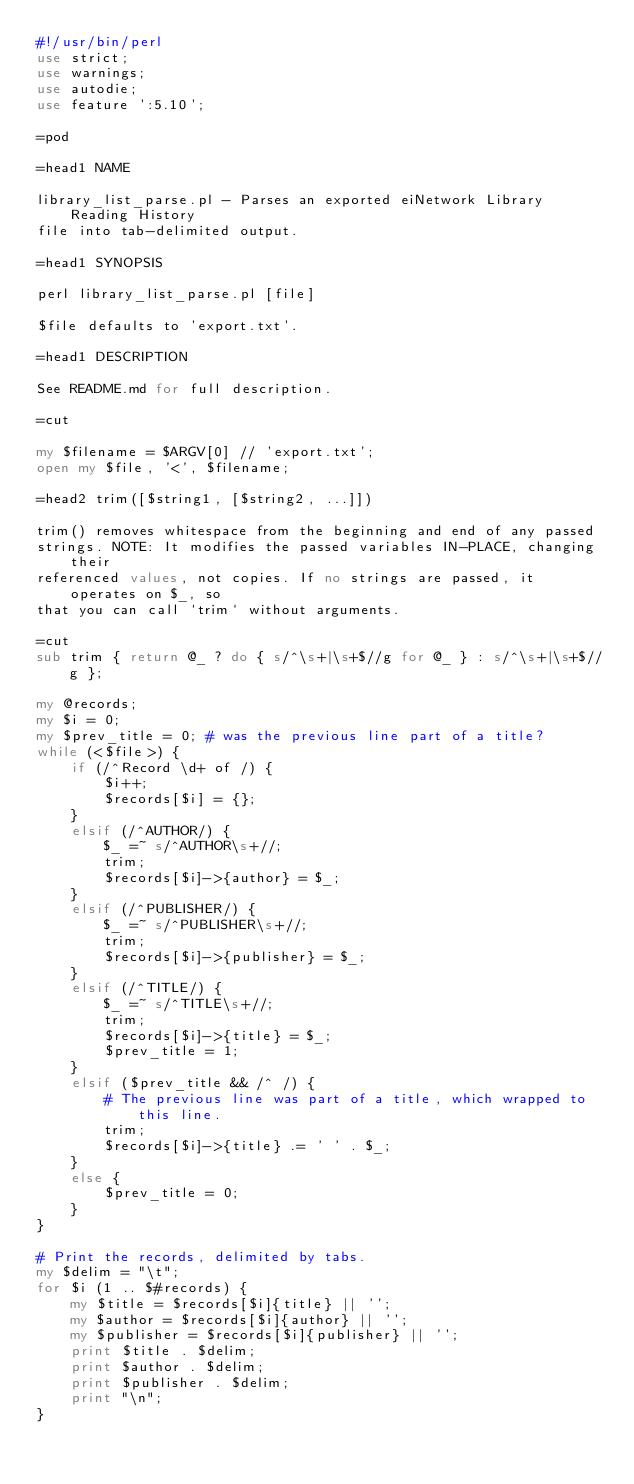Convert code to text. <code><loc_0><loc_0><loc_500><loc_500><_Perl_>#!/usr/bin/perl
use strict;
use warnings;
use autodie;
use feature ':5.10';

=pod

=head1 NAME

library_list_parse.pl - Parses an exported eiNetwork Library Reading History
file into tab-delimited output.

=head1 SYNOPSIS

perl library_list_parse.pl [file]

$file defaults to 'export.txt'.

=head1 DESCRIPTION

See README.md for full description.

=cut

my $filename = $ARGV[0] // 'export.txt';
open my $file, '<', $filename;

=head2 trim([$string1, [$string2, ...]])

trim() removes whitespace from the beginning and end of any passed
strings. NOTE: It modifies the passed variables IN-PLACE, changing their
referenced values, not copies. If no strings are passed, it operates on $_, so
that you can call `trim` without arguments.

=cut
sub trim { return @_ ? do { s/^\s+|\s+$//g for @_ } : s/^\s+|\s+$//g };

my @records;
my $i = 0;
my $prev_title = 0; # was the previous line part of a title?
while (<$file>) {
    if (/^Record \d+ of /) {
        $i++;
        $records[$i] = {};
    }
    elsif (/^AUTHOR/) {
        $_ =~ s/^AUTHOR\s+//;
        trim;
        $records[$i]->{author} = $_;
    }
    elsif (/^PUBLISHER/) {
        $_ =~ s/^PUBLISHER\s+//;
        trim;
        $records[$i]->{publisher} = $_;
    }
    elsif (/^TITLE/) {
        $_ =~ s/^TITLE\s+//;
        trim;
        $records[$i]->{title} = $_;
        $prev_title = 1;
    }
    elsif ($prev_title && /^ /) {
        # The previous line was part of a title, which wrapped to this line.
        trim;
        $records[$i]->{title} .= ' ' . $_;
    }
    else {
        $prev_title = 0;
    }
}

# Print the records, delimited by tabs.
my $delim = "\t";
for $i (1 .. $#records) {
    my $title = $records[$i]{title} || '';
    my $author = $records[$i]{author} || '';
    my $publisher = $records[$i]{publisher} || '';
    print $title . $delim;
    print $author . $delim;
    print $publisher . $delim;
    print "\n";
}
</code> 